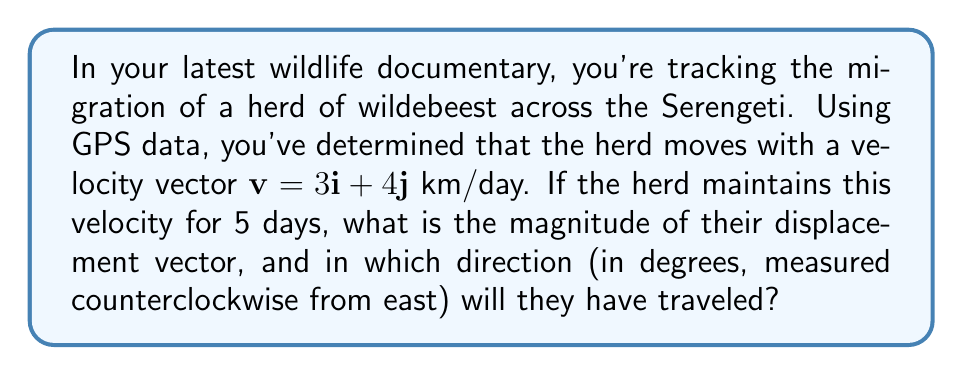Solve this math problem. 1) First, let's calculate the displacement vector after 5 days:
   $$\mathbf{d} = 5\mathbf{v} = 5(3\mathbf{i} + 4\mathbf{j}) = 15\mathbf{i} + 20\mathbf{j}$$ km

2) To find the magnitude of the displacement vector, we use the Pythagorean theorem:
   $$|\mathbf{d}| = \sqrt{15^2 + 20^2} = \sqrt{225 + 400} = \sqrt{625} = 25$$ km

3) To find the direction, we need to calculate the angle $\theta$ using the arctangent function:
   $$\theta = \arctan(\frac{y}{x}) = \arctan(\frac{20}{15}) = \arctan(\frac{4}{3})$$

4) Calculate this angle:
   $$\theta = \arctan(\frac{4}{3}) \approx 53.13°$$

5) This angle is measured counterclockwise from the positive x-axis (east), so it's already in the required format.
Answer: 25 km, 53.13° 